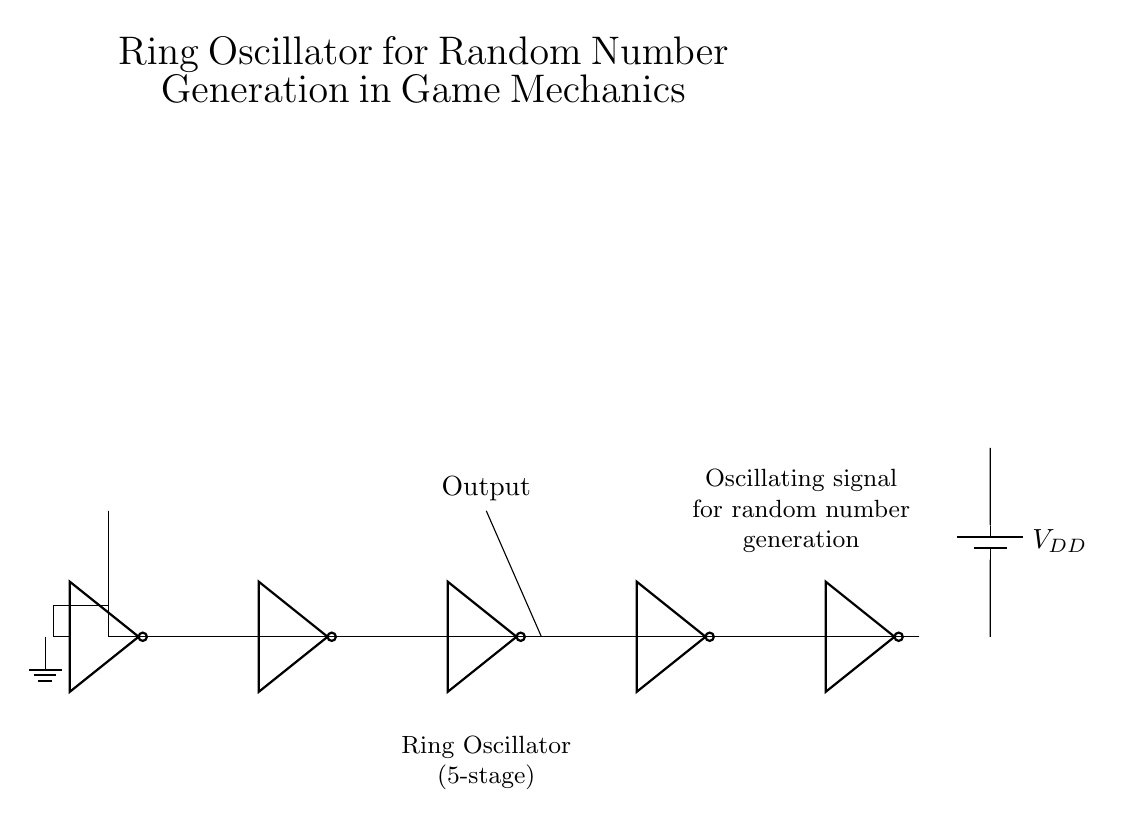What type of circuit is shown? The circuit is a ring oscillator, which consists of multiple inverters connected in a loop. The configuration allows for oscillation of the output between high and low states.
Answer: Ring oscillator How many inverters are used in this circuit? There are five inverters shown in the circuit, as indicated by the five distinct notation symbols labeled "not port."
Answer: Five What is the purpose of this circuit? The purpose of this circuit is for random number generation, as indicated by the annotations that mention it generates random signals for game mechanics.
Answer: Random number generation What does the output signal represent? The output signal represents the oscillation from the third inverter, which is indicated by the label above the line drawn from the inverter.
Answer: Oscillating signal What is the power supply voltage denoted as in this circuit? The power supply voltage is denoted as VDD, which is a common abbreviation used in circuit diagrams to represent the supply voltage.
Answer: VDD Explain how the inverters affect the output signal. The inverters each toggle the signal state; when one inverter outputs a high signal, the next in the sequence receives a low input, creating a chain reaction. This alternation establishes a rapidly oscillating output signal, contributing to the random number generation.
Answer: They toggle the signal state 